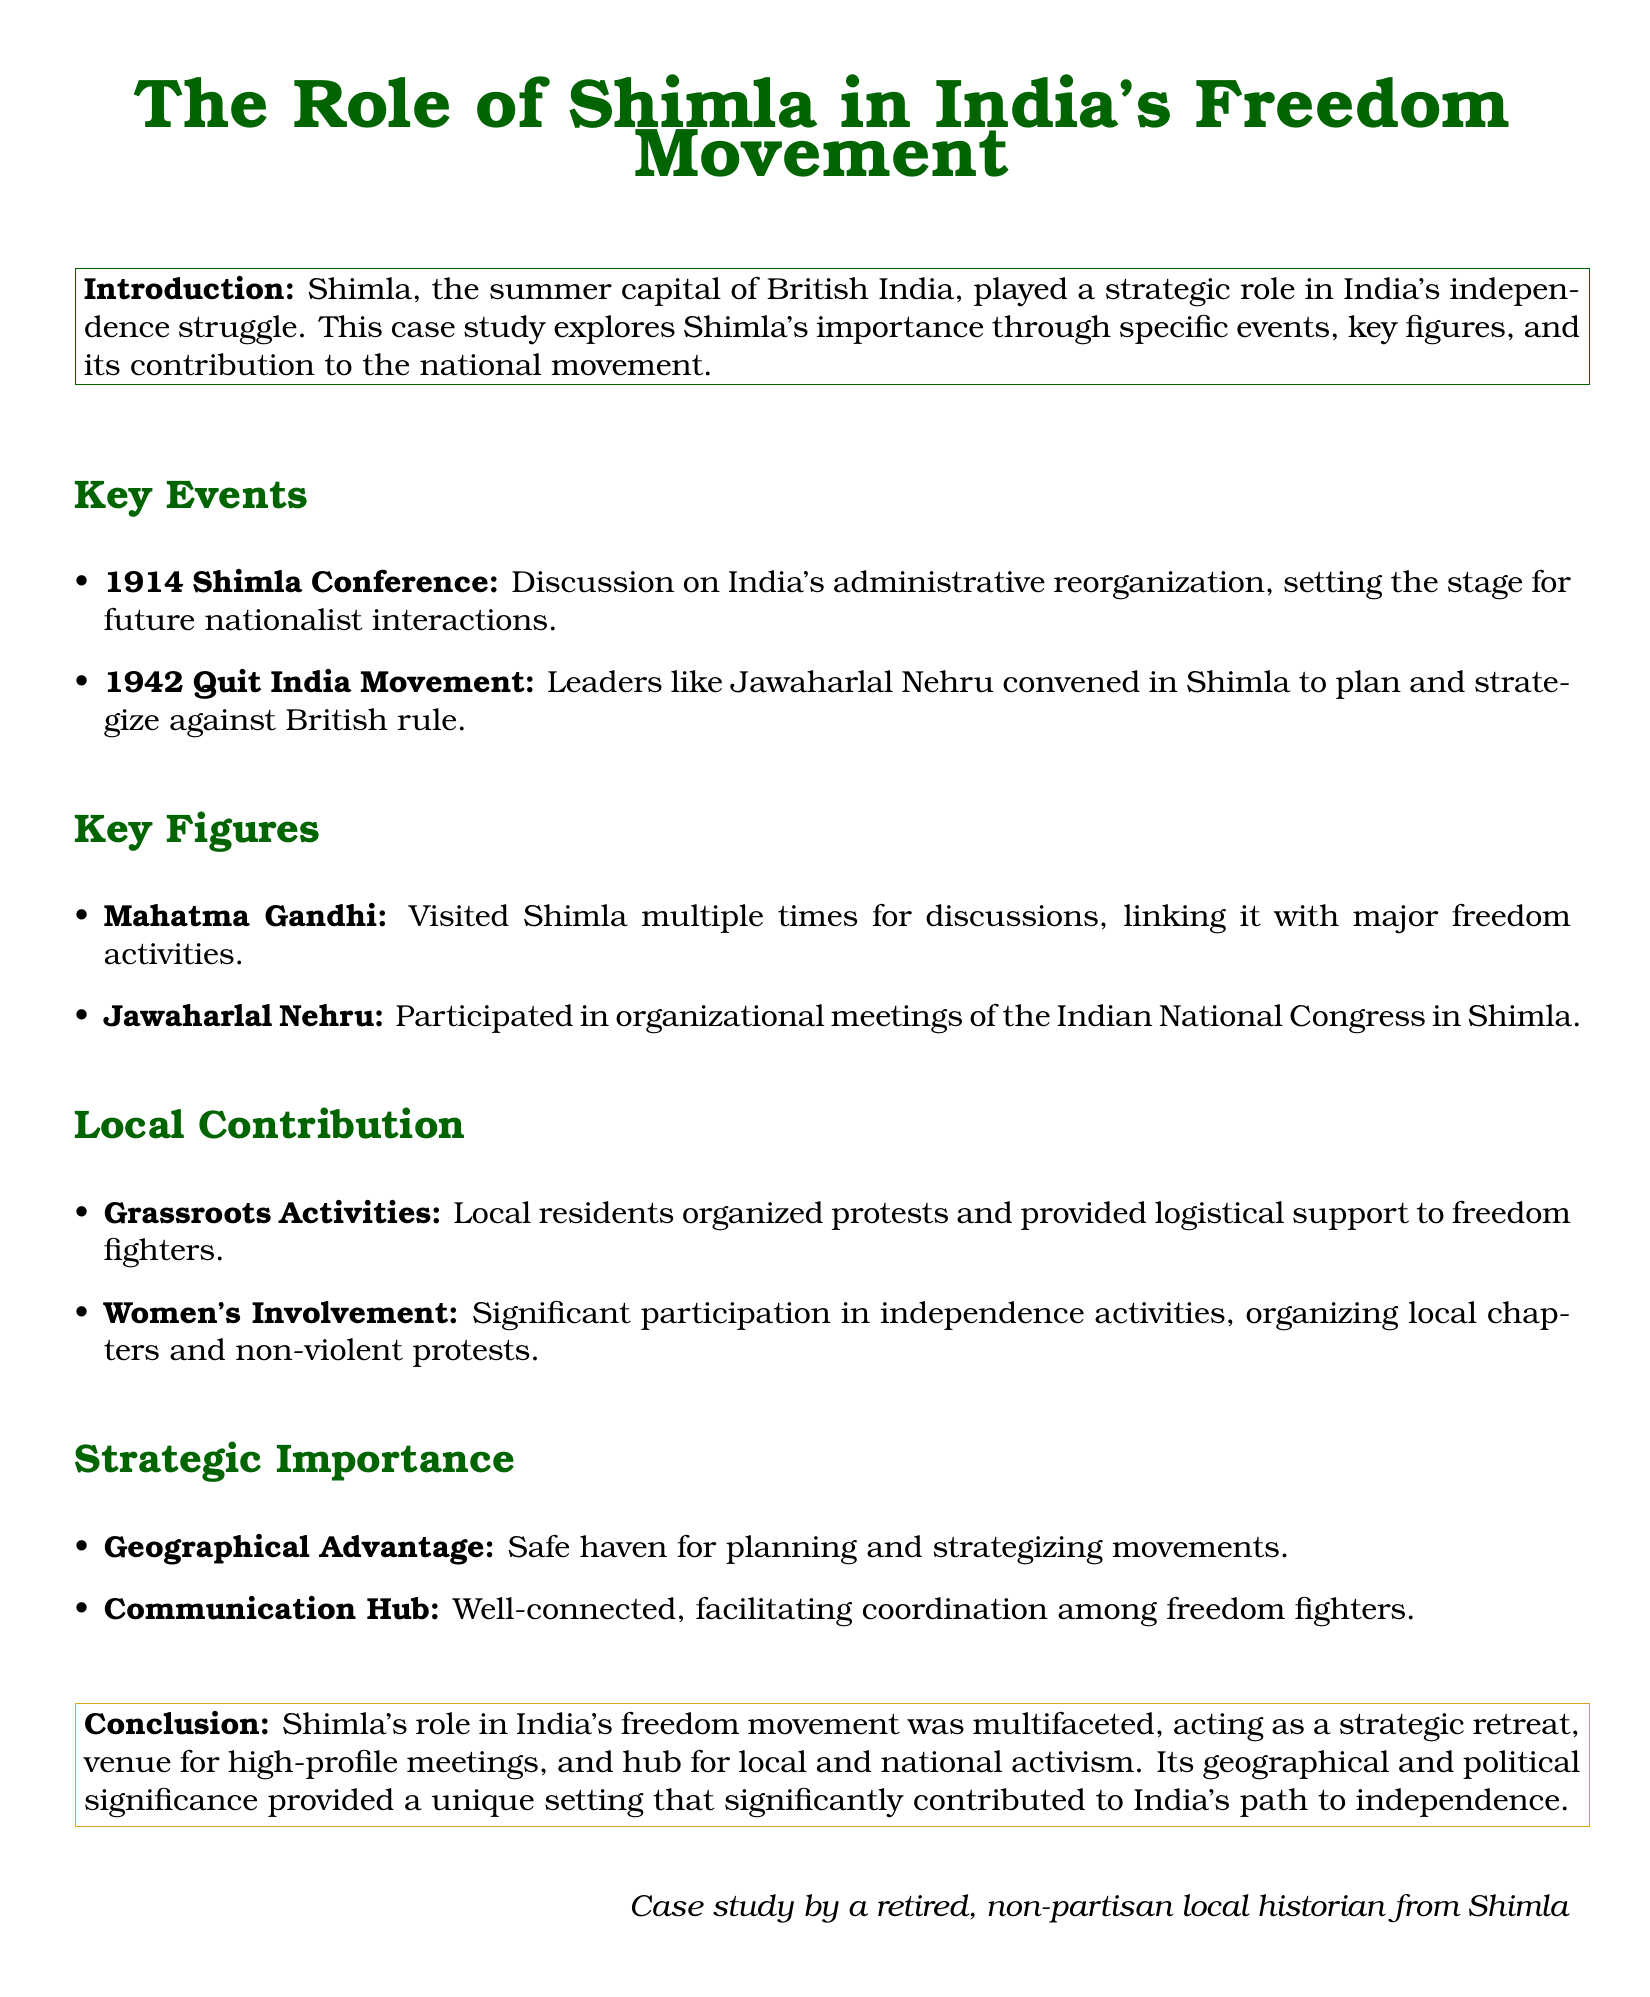What year did the Shimla Conference occur? The document states that the Shimla Conference took place in 1914.
Answer: 1914 Who were two key figures mentioned in the document? The document lists Mahatma Gandhi and Jawaharlal Nehru as significant figures in Shimla's contribution to the independence movement.
Answer: Mahatma Gandhi and Jawaharlal Nehru What movement was planned in Shimla in 1942? The document indicates that the Quit India Movement leaders convened in Shimla for strategizing against British rule.
Answer: Quit India Movement What type of local activities supported the freedom movement? The document mentions grassroots activities organized by local residents to support freedom fighters.
Answer: Grassroots Activities What geographical advantage did Shimla provide? The document denotes that Shimla served as a safe haven for planning and strategizing independence movements.
Answer: Safe haven How did women contribute to the independence activities? The document highlights women's significant participation in organizing local chapters and non-violent protests.
Answer: Organizing local chapters What was the overall role of Shimla described in the conclusion? The document concludes that Shimla acted as a strategic retreat, a venue for meetings, and a hub for activism.
Answer: Multifaceted role 